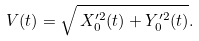<formula> <loc_0><loc_0><loc_500><loc_500>V ( t ) = \sqrt { \, X _ { 0 } ^ { \prime 2 } ( t ) + Y _ { 0 } ^ { \prime 2 } ( t ) } .</formula> 